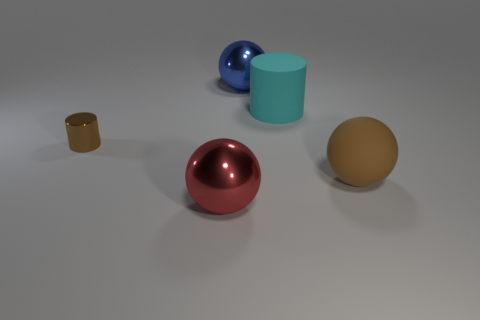Subtract all large brown balls. How many balls are left? 2 Subtract 1 cyan cylinders. How many objects are left? 4 Subtract all balls. How many objects are left? 2 Subtract 2 balls. How many balls are left? 1 Subtract all purple balls. Subtract all green cylinders. How many balls are left? 3 Subtract all blue cylinders. How many purple spheres are left? 0 Subtract all big cyan matte objects. Subtract all large matte balls. How many objects are left? 3 Add 3 small metal cylinders. How many small metal cylinders are left? 4 Add 3 big brown things. How many big brown things exist? 4 Add 4 small purple matte cylinders. How many objects exist? 9 